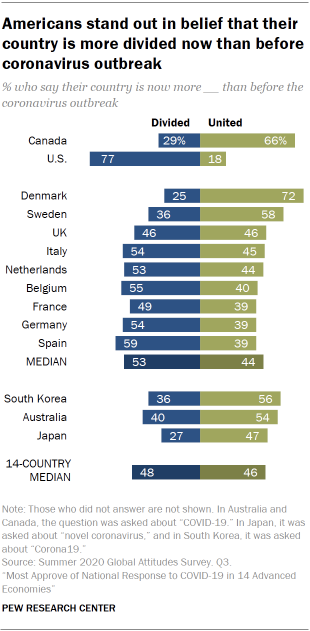Indicate a few pertinent items in this graphic. The ratio of the United States blue bar to the Netherlands green bar is 0.294444444... The percentage value of blue bars for Canada is 29%. 